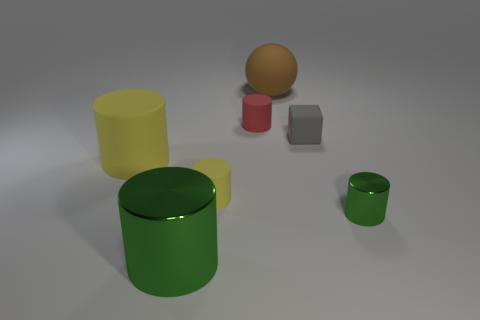There is a shiny thing right of the gray cube; is its shape the same as the tiny gray rubber thing? No, the shiny object to the right of the gray cube has a different shape. It appears to be spherical, while the tiny gray object has a cubical form. 